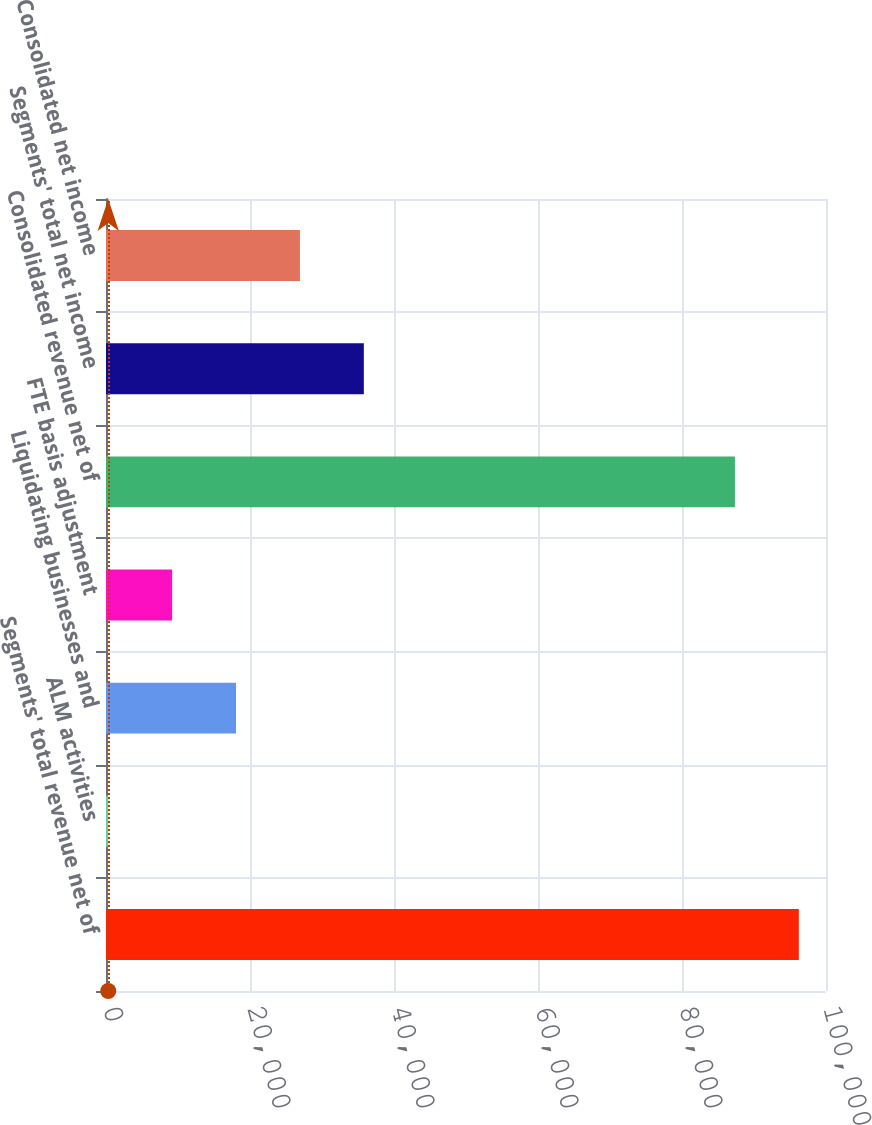Convert chart to OTSL. <chart><loc_0><loc_0><loc_500><loc_500><bar_chart><fcel>Segments' total revenue net of<fcel>ALM activities<fcel>Liquidating businesses and<fcel>FTE basis adjustment<fcel>Consolidated revenue net of<fcel>Segments' total net income<fcel>Consolidated net income<nl><fcel>96226.9<fcel>312<fcel>18061.8<fcel>9186.9<fcel>87352<fcel>35811.6<fcel>26936.7<nl></chart> 